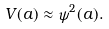<formula> <loc_0><loc_0><loc_500><loc_500>V ( a ) \approx \psi ^ { 2 } ( a ) .</formula> 